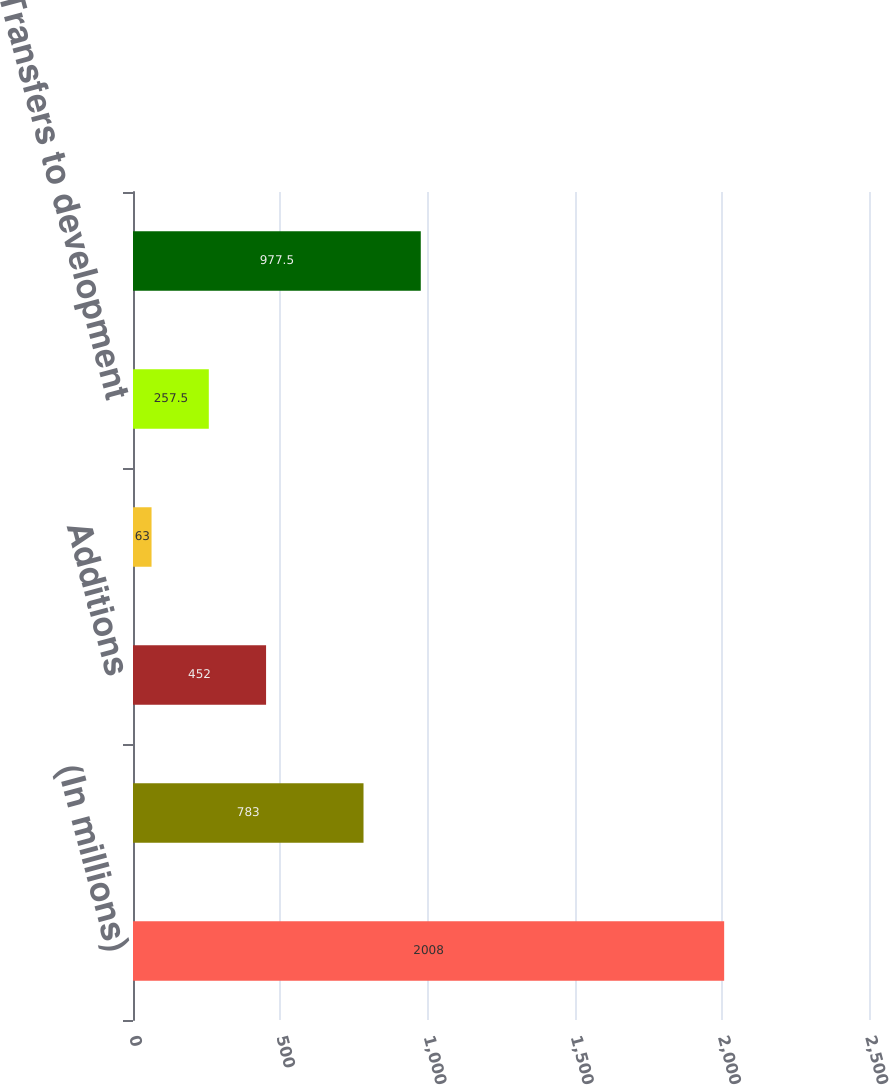Convert chart. <chart><loc_0><loc_0><loc_500><loc_500><bar_chart><fcel>(In millions)<fcel>Beginning Balance<fcel>Additions<fcel>Dry well expense<fcel>Transfers to development<fcel>Ending Balance<nl><fcel>2008<fcel>783<fcel>452<fcel>63<fcel>257.5<fcel>977.5<nl></chart> 